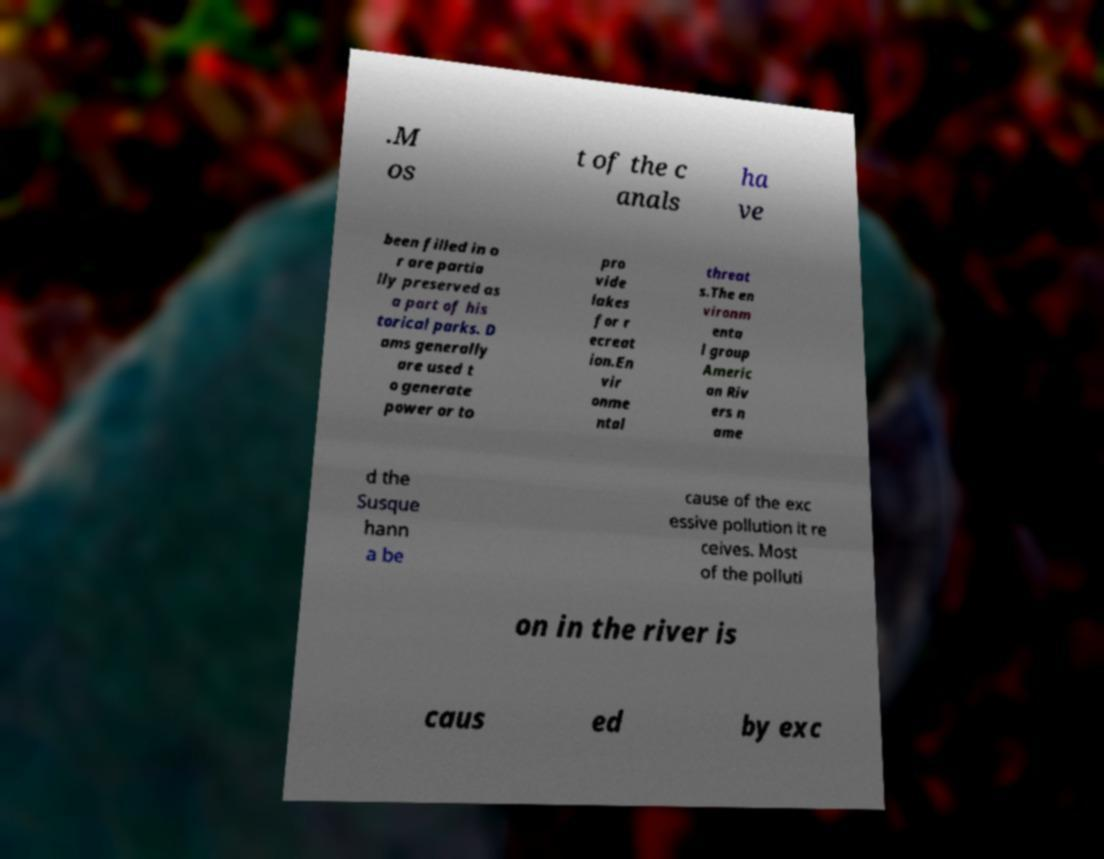Could you extract and type out the text from this image? .M os t of the c anals ha ve been filled in o r are partia lly preserved as a part of his torical parks. D ams generally are used t o generate power or to pro vide lakes for r ecreat ion.En vir onme ntal threat s.The en vironm enta l group Americ an Riv ers n ame d the Susque hann a be cause of the exc essive pollution it re ceives. Most of the polluti on in the river is caus ed by exc 